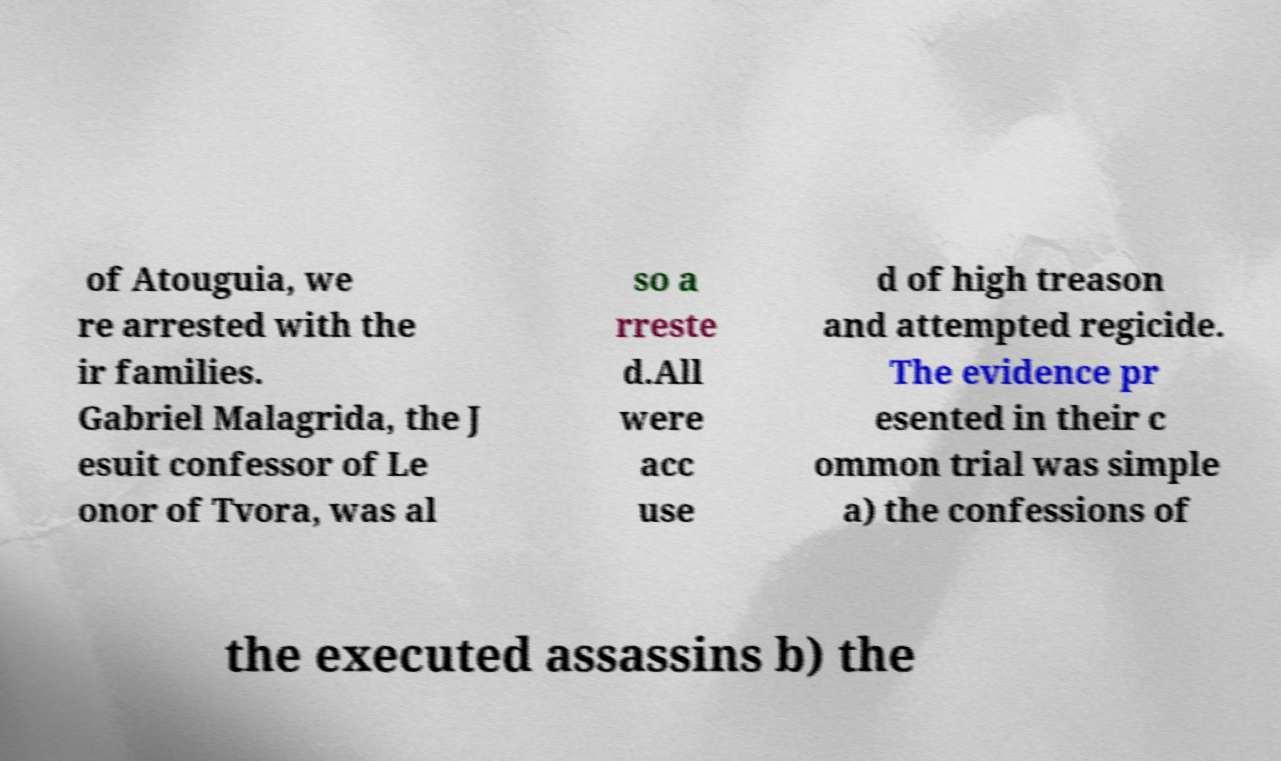Can you read and provide the text displayed in the image?This photo seems to have some interesting text. Can you extract and type it out for me? of Atouguia, we re arrested with the ir families. Gabriel Malagrida, the J esuit confessor of Le onor of Tvora, was al so a rreste d.All were acc use d of high treason and attempted regicide. The evidence pr esented in their c ommon trial was simple a) the confessions of the executed assassins b) the 